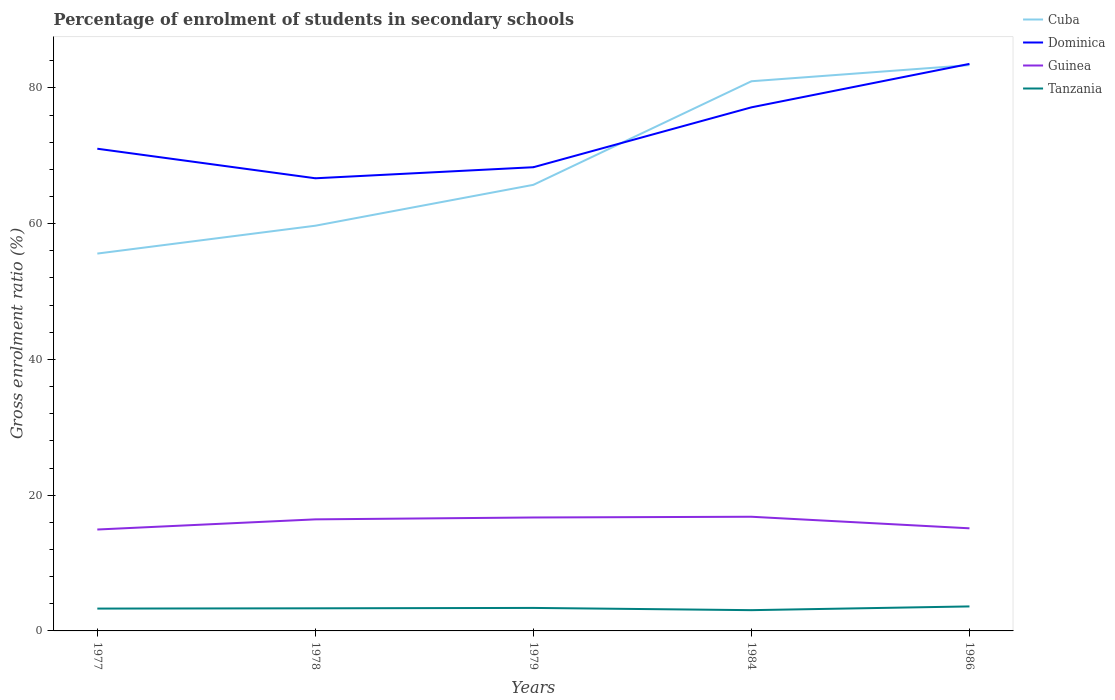How many different coloured lines are there?
Your answer should be compact. 4. Is the number of lines equal to the number of legend labels?
Offer a very short reply. Yes. Across all years, what is the maximum percentage of students enrolled in secondary schools in Tanzania?
Make the answer very short. 3.06. In which year was the percentage of students enrolled in secondary schools in Dominica maximum?
Give a very brief answer. 1978. What is the total percentage of students enrolled in secondary schools in Cuba in the graph?
Your answer should be compact. -10.13. What is the difference between the highest and the second highest percentage of students enrolled in secondary schools in Cuba?
Your response must be concise. 27.76. Is the percentage of students enrolled in secondary schools in Guinea strictly greater than the percentage of students enrolled in secondary schools in Tanzania over the years?
Give a very brief answer. No. Where does the legend appear in the graph?
Give a very brief answer. Top right. How many legend labels are there?
Your response must be concise. 4. How are the legend labels stacked?
Make the answer very short. Vertical. What is the title of the graph?
Ensure brevity in your answer.  Percentage of enrolment of students in secondary schools. Does "Greenland" appear as one of the legend labels in the graph?
Offer a very short reply. No. What is the label or title of the X-axis?
Give a very brief answer. Years. What is the label or title of the Y-axis?
Keep it short and to the point. Gross enrolment ratio (%). What is the Gross enrolment ratio (%) in Cuba in 1977?
Your answer should be compact. 55.59. What is the Gross enrolment ratio (%) in Dominica in 1977?
Offer a terse response. 71.03. What is the Gross enrolment ratio (%) in Guinea in 1977?
Ensure brevity in your answer.  14.94. What is the Gross enrolment ratio (%) in Tanzania in 1977?
Keep it short and to the point. 3.29. What is the Gross enrolment ratio (%) of Cuba in 1978?
Give a very brief answer. 59.69. What is the Gross enrolment ratio (%) of Dominica in 1978?
Provide a short and direct response. 66.68. What is the Gross enrolment ratio (%) of Guinea in 1978?
Your answer should be very brief. 16.44. What is the Gross enrolment ratio (%) of Tanzania in 1978?
Keep it short and to the point. 3.33. What is the Gross enrolment ratio (%) in Cuba in 1979?
Your answer should be compact. 65.72. What is the Gross enrolment ratio (%) of Dominica in 1979?
Give a very brief answer. 68.31. What is the Gross enrolment ratio (%) in Guinea in 1979?
Make the answer very short. 16.71. What is the Gross enrolment ratio (%) of Tanzania in 1979?
Your response must be concise. 3.39. What is the Gross enrolment ratio (%) of Cuba in 1984?
Your answer should be very brief. 80.97. What is the Gross enrolment ratio (%) in Dominica in 1984?
Your response must be concise. 77.13. What is the Gross enrolment ratio (%) of Guinea in 1984?
Provide a succinct answer. 16.82. What is the Gross enrolment ratio (%) in Tanzania in 1984?
Offer a very short reply. 3.06. What is the Gross enrolment ratio (%) in Cuba in 1986?
Your answer should be compact. 83.35. What is the Gross enrolment ratio (%) in Dominica in 1986?
Ensure brevity in your answer.  83.53. What is the Gross enrolment ratio (%) of Guinea in 1986?
Your response must be concise. 15.12. What is the Gross enrolment ratio (%) of Tanzania in 1986?
Make the answer very short. 3.61. Across all years, what is the maximum Gross enrolment ratio (%) in Cuba?
Your answer should be very brief. 83.35. Across all years, what is the maximum Gross enrolment ratio (%) in Dominica?
Offer a terse response. 83.53. Across all years, what is the maximum Gross enrolment ratio (%) in Guinea?
Offer a very short reply. 16.82. Across all years, what is the maximum Gross enrolment ratio (%) of Tanzania?
Give a very brief answer. 3.61. Across all years, what is the minimum Gross enrolment ratio (%) in Cuba?
Offer a very short reply. 55.59. Across all years, what is the minimum Gross enrolment ratio (%) in Dominica?
Provide a succinct answer. 66.68. Across all years, what is the minimum Gross enrolment ratio (%) of Guinea?
Your answer should be very brief. 14.94. Across all years, what is the minimum Gross enrolment ratio (%) of Tanzania?
Ensure brevity in your answer.  3.06. What is the total Gross enrolment ratio (%) of Cuba in the graph?
Your answer should be very brief. 345.32. What is the total Gross enrolment ratio (%) of Dominica in the graph?
Offer a very short reply. 366.69. What is the total Gross enrolment ratio (%) of Guinea in the graph?
Give a very brief answer. 80.02. What is the total Gross enrolment ratio (%) in Tanzania in the graph?
Your answer should be very brief. 16.68. What is the difference between the Gross enrolment ratio (%) in Cuba in 1977 and that in 1978?
Provide a succinct answer. -4.1. What is the difference between the Gross enrolment ratio (%) of Dominica in 1977 and that in 1978?
Keep it short and to the point. 4.35. What is the difference between the Gross enrolment ratio (%) in Guinea in 1977 and that in 1978?
Provide a succinct answer. -1.5. What is the difference between the Gross enrolment ratio (%) in Tanzania in 1977 and that in 1978?
Provide a short and direct response. -0.04. What is the difference between the Gross enrolment ratio (%) in Cuba in 1977 and that in 1979?
Give a very brief answer. -10.13. What is the difference between the Gross enrolment ratio (%) of Dominica in 1977 and that in 1979?
Ensure brevity in your answer.  2.73. What is the difference between the Gross enrolment ratio (%) of Guinea in 1977 and that in 1979?
Ensure brevity in your answer.  -1.77. What is the difference between the Gross enrolment ratio (%) of Tanzania in 1977 and that in 1979?
Your answer should be compact. -0.1. What is the difference between the Gross enrolment ratio (%) of Cuba in 1977 and that in 1984?
Provide a short and direct response. -25.39. What is the difference between the Gross enrolment ratio (%) of Dominica in 1977 and that in 1984?
Provide a succinct answer. -6.1. What is the difference between the Gross enrolment ratio (%) in Guinea in 1977 and that in 1984?
Your response must be concise. -1.88. What is the difference between the Gross enrolment ratio (%) of Tanzania in 1977 and that in 1984?
Give a very brief answer. 0.23. What is the difference between the Gross enrolment ratio (%) in Cuba in 1977 and that in 1986?
Keep it short and to the point. -27.76. What is the difference between the Gross enrolment ratio (%) in Dominica in 1977 and that in 1986?
Ensure brevity in your answer.  -12.5. What is the difference between the Gross enrolment ratio (%) in Guinea in 1977 and that in 1986?
Make the answer very short. -0.18. What is the difference between the Gross enrolment ratio (%) in Tanzania in 1977 and that in 1986?
Provide a succinct answer. -0.32. What is the difference between the Gross enrolment ratio (%) in Cuba in 1978 and that in 1979?
Offer a terse response. -6.02. What is the difference between the Gross enrolment ratio (%) in Dominica in 1978 and that in 1979?
Your answer should be very brief. -1.63. What is the difference between the Gross enrolment ratio (%) in Guinea in 1978 and that in 1979?
Offer a very short reply. -0.27. What is the difference between the Gross enrolment ratio (%) in Tanzania in 1978 and that in 1979?
Your answer should be very brief. -0.06. What is the difference between the Gross enrolment ratio (%) of Cuba in 1978 and that in 1984?
Your answer should be compact. -21.28. What is the difference between the Gross enrolment ratio (%) of Dominica in 1978 and that in 1984?
Make the answer very short. -10.45. What is the difference between the Gross enrolment ratio (%) of Guinea in 1978 and that in 1984?
Your answer should be compact. -0.38. What is the difference between the Gross enrolment ratio (%) in Tanzania in 1978 and that in 1984?
Your answer should be very brief. 0.27. What is the difference between the Gross enrolment ratio (%) of Cuba in 1978 and that in 1986?
Ensure brevity in your answer.  -23.66. What is the difference between the Gross enrolment ratio (%) of Dominica in 1978 and that in 1986?
Provide a succinct answer. -16.85. What is the difference between the Gross enrolment ratio (%) in Guinea in 1978 and that in 1986?
Offer a terse response. 1.32. What is the difference between the Gross enrolment ratio (%) in Tanzania in 1978 and that in 1986?
Your answer should be very brief. -0.28. What is the difference between the Gross enrolment ratio (%) in Cuba in 1979 and that in 1984?
Provide a succinct answer. -15.26. What is the difference between the Gross enrolment ratio (%) of Dominica in 1979 and that in 1984?
Provide a succinct answer. -8.82. What is the difference between the Gross enrolment ratio (%) of Guinea in 1979 and that in 1984?
Ensure brevity in your answer.  -0.11. What is the difference between the Gross enrolment ratio (%) in Tanzania in 1979 and that in 1984?
Make the answer very short. 0.33. What is the difference between the Gross enrolment ratio (%) of Cuba in 1979 and that in 1986?
Your answer should be very brief. -17.64. What is the difference between the Gross enrolment ratio (%) in Dominica in 1979 and that in 1986?
Give a very brief answer. -15.22. What is the difference between the Gross enrolment ratio (%) of Guinea in 1979 and that in 1986?
Provide a succinct answer. 1.59. What is the difference between the Gross enrolment ratio (%) of Tanzania in 1979 and that in 1986?
Provide a short and direct response. -0.22. What is the difference between the Gross enrolment ratio (%) in Cuba in 1984 and that in 1986?
Provide a short and direct response. -2.38. What is the difference between the Gross enrolment ratio (%) of Dominica in 1984 and that in 1986?
Offer a terse response. -6.4. What is the difference between the Gross enrolment ratio (%) of Guinea in 1984 and that in 1986?
Offer a very short reply. 1.7. What is the difference between the Gross enrolment ratio (%) in Tanzania in 1984 and that in 1986?
Keep it short and to the point. -0.55. What is the difference between the Gross enrolment ratio (%) in Cuba in 1977 and the Gross enrolment ratio (%) in Dominica in 1978?
Keep it short and to the point. -11.09. What is the difference between the Gross enrolment ratio (%) of Cuba in 1977 and the Gross enrolment ratio (%) of Guinea in 1978?
Give a very brief answer. 39.15. What is the difference between the Gross enrolment ratio (%) in Cuba in 1977 and the Gross enrolment ratio (%) in Tanzania in 1978?
Offer a very short reply. 52.26. What is the difference between the Gross enrolment ratio (%) in Dominica in 1977 and the Gross enrolment ratio (%) in Guinea in 1978?
Give a very brief answer. 54.6. What is the difference between the Gross enrolment ratio (%) in Dominica in 1977 and the Gross enrolment ratio (%) in Tanzania in 1978?
Give a very brief answer. 67.7. What is the difference between the Gross enrolment ratio (%) of Guinea in 1977 and the Gross enrolment ratio (%) of Tanzania in 1978?
Your answer should be very brief. 11.61. What is the difference between the Gross enrolment ratio (%) in Cuba in 1977 and the Gross enrolment ratio (%) in Dominica in 1979?
Offer a very short reply. -12.72. What is the difference between the Gross enrolment ratio (%) of Cuba in 1977 and the Gross enrolment ratio (%) of Guinea in 1979?
Your answer should be very brief. 38.88. What is the difference between the Gross enrolment ratio (%) in Cuba in 1977 and the Gross enrolment ratio (%) in Tanzania in 1979?
Keep it short and to the point. 52.2. What is the difference between the Gross enrolment ratio (%) in Dominica in 1977 and the Gross enrolment ratio (%) in Guinea in 1979?
Your answer should be compact. 54.32. What is the difference between the Gross enrolment ratio (%) of Dominica in 1977 and the Gross enrolment ratio (%) of Tanzania in 1979?
Provide a succinct answer. 67.65. What is the difference between the Gross enrolment ratio (%) in Guinea in 1977 and the Gross enrolment ratio (%) in Tanzania in 1979?
Offer a very short reply. 11.55. What is the difference between the Gross enrolment ratio (%) in Cuba in 1977 and the Gross enrolment ratio (%) in Dominica in 1984?
Give a very brief answer. -21.54. What is the difference between the Gross enrolment ratio (%) of Cuba in 1977 and the Gross enrolment ratio (%) of Guinea in 1984?
Your answer should be compact. 38.77. What is the difference between the Gross enrolment ratio (%) in Cuba in 1977 and the Gross enrolment ratio (%) in Tanzania in 1984?
Make the answer very short. 52.53. What is the difference between the Gross enrolment ratio (%) in Dominica in 1977 and the Gross enrolment ratio (%) in Guinea in 1984?
Give a very brief answer. 54.21. What is the difference between the Gross enrolment ratio (%) in Dominica in 1977 and the Gross enrolment ratio (%) in Tanzania in 1984?
Provide a short and direct response. 67.98. What is the difference between the Gross enrolment ratio (%) of Guinea in 1977 and the Gross enrolment ratio (%) of Tanzania in 1984?
Provide a succinct answer. 11.88. What is the difference between the Gross enrolment ratio (%) in Cuba in 1977 and the Gross enrolment ratio (%) in Dominica in 1986?
Ensure brevity in your answer.  -27.94. What is the difference between the Gross enrolment ratio (%) of Cuba in 1977 and the Gross enrolment ratio (%) of Guinea in 1986?
Give a very brief answer. 40.47. What is the difference between the Gross enrolment ratio (%) of Cuba in 1977 and the Gross enrolment ratio (%) of Tanzania in 1986?
Ensure brevity in your answer.  51.98. What is the difference between the Gross enrolment ratio (%) in Dominica in 1977 and the Gross enrolment ratio (%) in Guinea in 1986?
Your answer should be very brief. 55.92. What is the difference between the Gross enrolment ratio (%) of Dominica in 1977 and the Gross enrolment ratio (%) of Tanzania in 1986?
Ensure brevity in your answer.  67.42. What is the difference between the Gross enrolment ratio (%) of Guinea in 1977 and the Gross enrolment ratio (%) of Tanzania in 1986?
Your answer should be compact. 11.33. What is the difference between the Gross enrolment ratio (%) of Cuba in 1978 and the Gross enrolment ratio (%) of Dominica in 1979?
Your answer should be very brief. -8.62. What is the difference between the Gross enrolment ratio (%) of Cuba in 1978 and the Gross enrolment ratio (%) of Guinea in 1979?
Make the answer very short. 42.98. What is the difference between the Gross enrolment ratio (%) of Cuba in 1978 and the Gross enrolment ratio (%) of Tanzania in 1979?
Provide a succinct answer. 56.31. What is the difference between the Gross enrolment ratio (%) in Dominica in 1978 and the Gross enrolment ratio (%) in Guinea in 1979?
Ensure brevity in your answer.  49.97. What is the difference between the Gross enrolment ratio (%) of Dominica in 1978 and the Gross enrolment ratio (%) of Tanzania in 1979?
Your answer should be compact. 63.29. What is the difference between the Gross enrolment ratio (%) in Guinea in 1978 and the Gross enrolment ratio (%) in Tanzania in 1979?
Your answer should be compact. 13.05. What is the difference between the Gross enrolment ratio (%) in Cuba in 1978 and the Gross enrolment ratio (%) in Dominica in 1984?
Offer a very short reply. -17.44. What is the difference between the Gross enrolment ratio (%) in Cuba in 1978 and the Gross enrolment ratio (%) in Guinea in 1984?
Provide a succinct answer. 42.87. What is the difference between the Gross enrolment ratio (%) of Cuba in 1978 and the Gross enrolment ratio (%) of Tanzania in 1984?
Offer a terse response. 56.63. What is the difference between the Gross enrolment ratio (%) of Dominica in 1978 and the Gross enrolment ratio (%) of Guinea in 1984?
Provide a short and direct response. 49.86. What is the difference between the Gross enrolment ratio (%) of Dominica in 1978 and the Gross enrolment ratio (%) of Tanzania in 1984?
Make the answer very short. 63.62. What is the difference between the Gross enrolment ratio (%) in Guinea in 1978 and the Gross enrolment ratio (%) in Tanzania in 1984?
Your answer should be compact. 13.38. What is the difference between the Gross enrolment ratio (%) of Cuba in 1978 and the Gross enrolment ratio (%) of Dominica in 1986?
Offer a terse response. -23.84. What is the difference between the Gross enrolment ratio (%) in Cuba in 1978 and the Gross enrolment ratio (%) in Guinea in 1986?
Give a very brief answer. 44.58. What is the difference between the Gross enrolment ratio (%) of Cuba in 1978 and the Gross enrolment ratio (%) of Tanzania in 1986?
Your answer should be compact. 56.08. What is the difference between the Gross enrolment ratio (%) in Dominica in 1978 and the Gross enrolment ratio (%) in Guinea in 1986?
Offer a very short reply. 51.57. What is the difference between the Gross enrolment ratio (%) of Dominica in 1978 and the Gross enrolment ratio (%) of Tanzania in 1986?
Ensure brevity in your answer.  63.07. What is the difference between the Gross enrolment ratio (%) in Guinea in 1978 and the Gross enrolment ratio (%) in Tanzania in 1986?
Your answer should be compact. 12.83. What is the difference between the Gross enrolment ratio (%) of Cuba in 1979 and the Gross enrolment ratio (%) of Dominica in 1984?
Offer a very short reply. -11.42. What is the difference between the Gross enrolment ratio (%) in Cuba in 1979 and the Gross enrolment ratio (%) in Guinea in 1984?
Keep it short and to the point. 48.9. What is the difference between the Gross enrolment ratio (%) in Cuba in 1979 and the Gross enrolment ratio (%) in Tanzania in 1984?
Provide a succinct answer. 62.66. What is the difference between the Gross enrolment ratio (%) in Dominica in 1979 and the Gross enrolment ratio (%) in Guinea in 1984?
Your response must be concise. 51.49. What is the difference between the Gross enrolment ratio (%) of Dominica in 1979 and the Gross enrolment ratio (%) of Tanzania in 1984?
Your answer should be very brief. 65.25. What is the difference between the Gross enrolment ratio (%) of Guinea in 1979 and the Gross enrolment ratio (%) of Tanzania in 1984?
Provide a short and direct response. 13.65. What is the difference between the Gross enrolment ratio (%) of Cuba in 1979 and the Gross enrolment ratio (%) of Dominica in 1986?
Make the answer very short. -17.82. What is the difference between the Gross enrolment ratio (%) of Cuba in 1979 and the Gross enrolment ratio (%) of Guinea in 1986?
Your response must be concise. 50.6. What is the difference between the Gross enrolment ratio (%) in Cuba in 1979 and the Gross enrolment ratio (%) in Tanzania in 1986?
Provide a succinct answer. 62.11. What is the difference between the Gross enrolment ratio (%) in Dominica in 1979 and the Gross enrolment ratio (%) in Guinea in 1986?
Give a very brief answer. 53.19. What is the difference between the Gross enrolment ratio (%) in Dominica in 1979 and the Gross enrolment ratio (%) in Tanzania in 1986?
Give a very brief answer. 64.7. What is the difference between the Gross enrolment ratio (%) in Guinea in 1979 and the Gross enrolment ratio (%) in Tanzania in 1986?
Your response must be concise. 13.1. What is the difference between the Gross enrolment ratio (%) in Cuba in 1984 and the Gross enrolment ratio (%) in Dominica in 1986?
Keep it short and to the point. -2.56. What is the difference between the Gross enrolment ratio (%) in Cuba in 1984 and the Gross enrolment ratio (%) in Guinea in 1986?
Make the answer very short. 65.86. What is the difference between the Gross enrolment ratio (%) of Cuba in 1984 and the Gross enrolment ratio (%) of Tanzania in 1986?
Make the answer very short. 77.36. What is the difference between the Gross enrolment ratio (%) in Dominica in 1984 and the Gross enrolment ratio (%) in Guinea in 1986?
Provide a short and direct response. 62.02. What is the difference between the Gross enrolment ratio (%) in Dominica in 1984 and the Gross enrolment ratio (%) in Tanzania in 1986?
Ensure brevity in your answer.  73.52. What is the difference between the Gross enrolment ratio (%) of Guinea in 1984 and the Gross enrolment ratio (%) of Tanzania in 1986?
Provide a short and direct response. 13.21. What is the average Gross enrolment ratio (%) of Cuba per year?
Provide a short and direct response. 69.06. What is the average Gross enrolment ratio (%) of Dominica per year?
Ensure brevity in your answer.  73.34. What is the average Gross enrolment ratio (%) in Guinea per year?
Offer a very short reply. 16. What is the average Gross enrolment ratio (%) in Tanzania per year?
Your answer should be very brief. 3.34. In the year 1977, what is the difference between the Gross enrolment ratio (%) of Cuba and Gross enrolment ratio (%) of Dominica?
Provide a succinct answer. -15.45. In the year 1977, what is the difference between the Gross enrolment ratio (%) in Cuba and Gross enrolment ratio (%) in Guinea?
Provide a short and direct response. 40.65. In the year 1977, what is the difference between the Gross enrolment ratio (%) of Cuba and Gross enrolment ratio (%) of Tanzania?
Your answer should be compact. 52.3. In the year 1977, what is the difference between the Gross enrolment ratio (%) of Dominica and Gross enrolment ratio (%) of Guinea?
Keep it short and to the point. 56.1. In the year 1977, what is the difference between the Gross enrolment ratio (%) of Dominica and Gross enrolment ratio (%) of Tanzania?
Ensure brevity in your answer.  67.74. In the year 1977, what is the difference between the Gross enrolment ratio (%) of Guinea and Gross enrolment ratio (%) of Tanzania?
Ensure brevity in your answer.  11.65. In the year 1978, what is the difference between the Gross enrolment ratio (%) in Cuba and Gross enrolment ratio (%) in Dominica?
Keep it short and to the point. -6.99. In the year 1978, what is the difference between the Gross enrolment ratio (%) of Cuba and Gross enrolment ratio (%) of Guinea?
Give a very brief answer. 43.26. In the year 1978, what is the difference between the Gross enrolment ratio (%) of Cuba and Gross enrolment ratio (%) of Tanzania?
Your answer should be very brief. 56.36. In the year 1978, what is the difference between the Gross enrolment ratio (%) of Dominica and Gross enrolment ratio (%) of Guinea?
Your response must be concise. 50.25. In the year 1978, what is the difference between the Gross enrolment ratio (%) of Dominica and Gross enrolment ratio (%) of Tanzania?
Offer a very short reply. 63.35. In the year 1978, what is the difference between the Gross enrolment ratio (%) in Guinea and Gross enrolment ratio (%) in Tanzania?
Keep it short and to the point. 13.1. In the year 1979, what is the difference between the Gross enrolment ratio (%) in Cuba and Gross enrolment ratio (%) in Dominica?
Give a very brief answer. -2.59. In the year 1979, what is the difference between the Gross enrolment ratio (%) of Cuba and Gross enrolment ratio (%) of Guinea?
Your answer should be compact. 49.01. In the year 1979, what is the difference between the Gross enrolment ratio (%) in Cuba and Gross enrolment ratio (%) in Tanzania?
Your answer should be very brief. 62.33. In the year 1979, what is the difference between the Gross enrolment ratio (%) of Dominica and Gross enrolment ratio (%) of Guinea?
Give a very brief answer. 51.6. In the year 1979, what is the difference between the Gross enrolment ratio (%) of Dominica and Gross enrolment ratio (%) of Tanzania?
Ensure brevity in your answer.  64.92. In the year 1979, what is the difference between the Gross enrolment ratio (%) of Guinea and Gross enrolment ratio (%) of Tanzania?
Offer a very short reply. 13.32. In the year 1984, what is the difference between the Gross enrolment ratio (%) of Cuba and Gross enrolment ratio (%) of Dominica?
Give a very brief answer. 3.84. In the year 1984, what is the difference between the Gross enrolment ratio (%) in Cuba and Gross enrolment ratio (%) in Guinea?
Provide a succinct answer. 64.15. In the year 1984, what is the difference between the Gross enrolment ratio (%) in Cuba and Gross enrolment ratio (%) in Tanzania?
Give a very brief answer. 77.92. In the year 1984, what is the difference between the Gross enrolment ratio (%) in Dominica and Gross enrolment ratio (%) in Guinea?
Make the answer very short. 60.31. In the year 1984, what is the difference between the Gross enrolment ratio (%) in Dominica and Gross enrolment ratio (%) in Tanzania?
Provide a short and direct response. 74.07. In the year 1984, what is the difference between the Gross enrolment ratio (%) in Guinea and Gross enrolment ratio (%) in Tanzania?
Offer a terse response. 13.76. In the year 1986, what is the difference between the Gross enrolment ratio (%) in Cuba and Gross enrolment ratio (%) in Dominica?
Offer a terse response. -0.18. In the year 1986, what is the difference between the Gross enrolment ratio (%) in Cuba and Gross enrolment ratio (%) in Guinea?
Your answer should be very brief. 68.24. In the year 1986, what is the difference between the Gross enrolment ratio (%) of Cuba and Gross enrolment ratio (%) of Tanzania?
Offer a very short reply. 79.74. In the year 1986, what is the difference between the Gross enrolment ratio (%) in Dominica and Gross enrolment ratio (%) in Guinea?
Offer a terse response. 68.42. In the year 1986, what is the difference between the Gross enrolment ratio (%) in Dominica and Gross enrolment ratio (%) in Tanzania?
Provide a short and direct response. 79.92. In the year 1986, what is the difference between the Gross enrolment ratio (%) of Guinea and Gross enrolment ratio (%) of Tanzania?
Ensure brevity in your answer.  11.51. What is the ratio of the Gross enrolment ratio (%) in Cuba in 1977 to that in 1978?
Offer a very short reply. 0.93. What is the ratio of the Gross enrolment ratio (%) in Dominica in 1977 to that in 1978?
Keep it short and to the point. 1.07. What is the ratio of the Gross enrolment ratio (%) of Guinea in 1977 to that in 1978?
Your answer should be compact. 0.91. What is the ratio of the Gross enrolment ratio (%) in Tanzania in 1977 to that in 1978?
Make the answer very short. 0.99. What is the ratio of the Gross enrolment ratio (%) in Cuba in 1977 to that in 1979?
Keep it short and to the point. 0.85. What is the ratio of the Gross enrolment ratio (%) in Dominica in 1977 to that in 1979?
Your response must be concise. 1.04. What is the ratio of the Gross enrolment ratio (%) in Guinea in 1977 to that in 1979?
Provide a short and direct response. 0.89. What is the ratio of the Gross enrolment ratio (%) in Tanzania in 1977 to that in 1979?
Your response must be concise. 0.97. What is the ratio of the Gross enrolment ratio (%) in Cuba in 1977 to that in 1984?
Offer a terse response. 0.69. What is the ratio of the Gross enrolment ratio (%) in Dominica in 1977 to that in 1984?
Provide a short and direct response. 0.92. What is the ratio of the Gross enrolment ratio (%) in Guinea in 1977 to that in 1984?
Your answer should be very brief. 0.89. What is the ratio of the Gross enrolment ratio (%) in Tanzania in 1977 to that in 1984?
Ensure brevity in your answer.  1.08. What is the ratio of the Gross enrolment ratio (%) in Cuba in 1977 to that in 1986?
Provide a succinct answer. 0.67. What is the ratio of the Gross enrolment ratio (%) in Dominica in 1977 to that in 1986?
Your answer should be compact. 0.85. What is the ratio of the Gross enrolment ratio (%) of Guinea in 1977 to that in 1986?
Ensure brevity in your answer.  0.99. What is the ratio of the Gross enrolment ratio (%) in Tanzania in 1977 to that in 1986?
Your answer should be compact. 0.91. What is the ratio of the Gross enrolment ratio (%) in Cuba in 1978 to that in 1979?
Provide a short and direct response. 0.91. What is the ratio of the Gross enrolment ratio (%) of Dominica in 1978 to that in 1979?
Provide a succinct answer. 0.98. What is the ratio of the Gross enrolment ratio (%) of Guinea in 1978 to that in 1979?
Your answer should be very brief. 0.98. What is the ratio of the Gross enrolment ratio (%) of Tanzania in 1978 to that in 1979?
Your answer should be very brief. 0.98. What is the ratio of the Gross enrolment ratio (%) of Cuba in 1978 to that in 1984?
Your answer should be very brief. 0.74. What is the ratio of the Gross enrolment ratio (%) in Dominica in 1978 to that in 1984?
Your response must be concise. 0.86. What is the ratio of the Gross enrolment ratio (%) in Guinea in 1978 to that in 1984?
Offer a very short reply. 0.98. What is the ratio of the Gross enrolment ratio (%) in Tanzania in 1978 to that in 1984?
Give a very brief answer. 1.09. What is the ratio of the Gross enrolment ratio (%) in Cuba in 1978 to that in 1986?
Give a very brief answer. 0.72. What is the ratio of the Gross enrolment ratio (%) in Dominica in 1978 to that in 1986?
Offer a terse response. 0.8. What is the ratio of the Gross enrolment ratio (%) in Guinea in 1978 to that in 1986?
Provide a short and direct response. 1.09. What is the ratio of the Gross enrolment ratio (%) in Tanzania in 1978 to that in 1986?
Your answer should be compact. 0.92. What is the ratio of the Gross enrolment ratio (%) of Cuba in 1979 to that in 1984?
Your response must be concise. 0.81. What is the ratio of the Gross enrolment ratio (%) of Dominica in 1979 to that in 1984?
Provide a short and direct response. 0.89. What is the ratio of the Gross enrolment ratio (%) of Guinea in 1979 to that in 1984?
Make the answer very short. 0.99. What is the ratio of the Gross enrolment ratio (%) in Tanzania in 1979 to that in 1984?
Offer a terse response. 1.11. What is the ratio of the Gross enrolment ratio (%) of Cuba in 1979 to that in 1986?
Your answer should be very brief. 0.79. What is the ratio of the Gross enrolment ratio (%) in Dominica in 1979 to that in 1986?
Offer a terse response. 0.82. What is the ratio of the Gross enrolment ratio (%) in Guinea in 1979 to that in 1986?
Your answer should be very brief. 1.11. What is the ratio of the Gross enrolment ratio (%) in Tanzania in 1979 to that in 1986?
Your response must be concise. 0.94. What is the ratio of the Gross enrolment ratio (%) in Cuba in 1984 to that in 1986?
Give a very brief answer. 0.97. What is the ratio of the Gross enrolment ratio (%) of Dominica in 1984 to that in 1986?
Provide a succinct answer. 0.92. What is the ratio of the Gross enrolment ratio (%) in Guinea in 1984 to that in 1986?
Offer a very short reply. 1.11. What is the ratio of the Gross enrolment ratio (%) of Tanzania in 1984 to that in 1986?
Provide a succinct answer. 0.85. What is the difference between the highest and the second highest Gross enrolment ratio (%) in Cuba?
Ensure brevity in your answer.  2.38. What is the difference between the highest and the second highest Gross enrolment ratio (%) of Dominica?
Provide a succinct answer. 6.4. What is the difference between the highest and the second highest Gross enrolment ratio (%) in Guinea?
Ensure brevity in your answer.  0.11. What is the difference between the highest and the second highest Gross enrolment ratio (%) of Tanzania?
Give a very brief answer. 0.22. What is the difference between the highest and the lowest Gross enrolment ratio (%) in Cuba?
Give a very brief answer. 27.76. What is the difference between the highest and the lowest Gross enrolment ratio (%) in Dominica?
Provide a short and direct response. 16.85. What is the difference between the highest and the lowest Gross enrolment ratio (%) of Guinea?
Your response must be concise. 1.88. What is the difference between the highest and the lowest Gross enrolment ratio (%) of Tanzania?
Offer a very short reply. 0.55. 